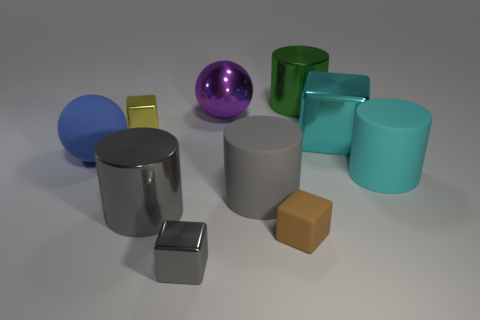How many tiny cubes are both on the right side of the large gray rubber cylinder and in front of the matte cube?
Ensure brevity in your answer.  0. There is a yellow object that is the same size as the brown matte cube; what is its shape?
Ensure brevity in your answer.  Cube. How big is the yellow thing?
Provide a succinct answer. Small. What material is the tiny cube to the left of the small shiny block that is in front of the large ball in front of the yellow shiny object?
Offer a terse response. Metal. What is the color of the other tiny object that is made of the same material as the blue object?
Your answer should be very brief. Brown. How many things are in front of the big metallic cylinder in front of the small object that is left of the gray metal cylinder?
Offer a very short reply. 2. There is a large thing that is the same color as the large block; what material is it?
Make the answer very short. Rubber. Is there any other thing that has the same shape as the big cyan shiny thing?
Offer a terse response. Yes. What number of objects are metallic things that are behind the large cyan cylinder or brown matte cubes?
Give a very brief answer. 5. Does the matte thing on the left side of the large gray matte cylinder have the same color as the rubber cube?
Provide a succinct answer. No. 